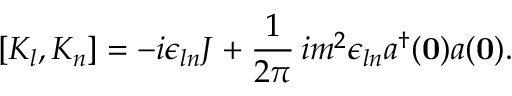<formula> <loc_0><loc_0><loc_500><loc_500>[ K _ { l } , K _ { n } ] = - i \epsilon _ { \ln } J + \frac { 1 } { 2 \pi } \, i m ^ { 2 } \epsilon _ { \ln } a ^ { \dagger } ( { 0 } ) a ( { 0 } ) .</formula> 